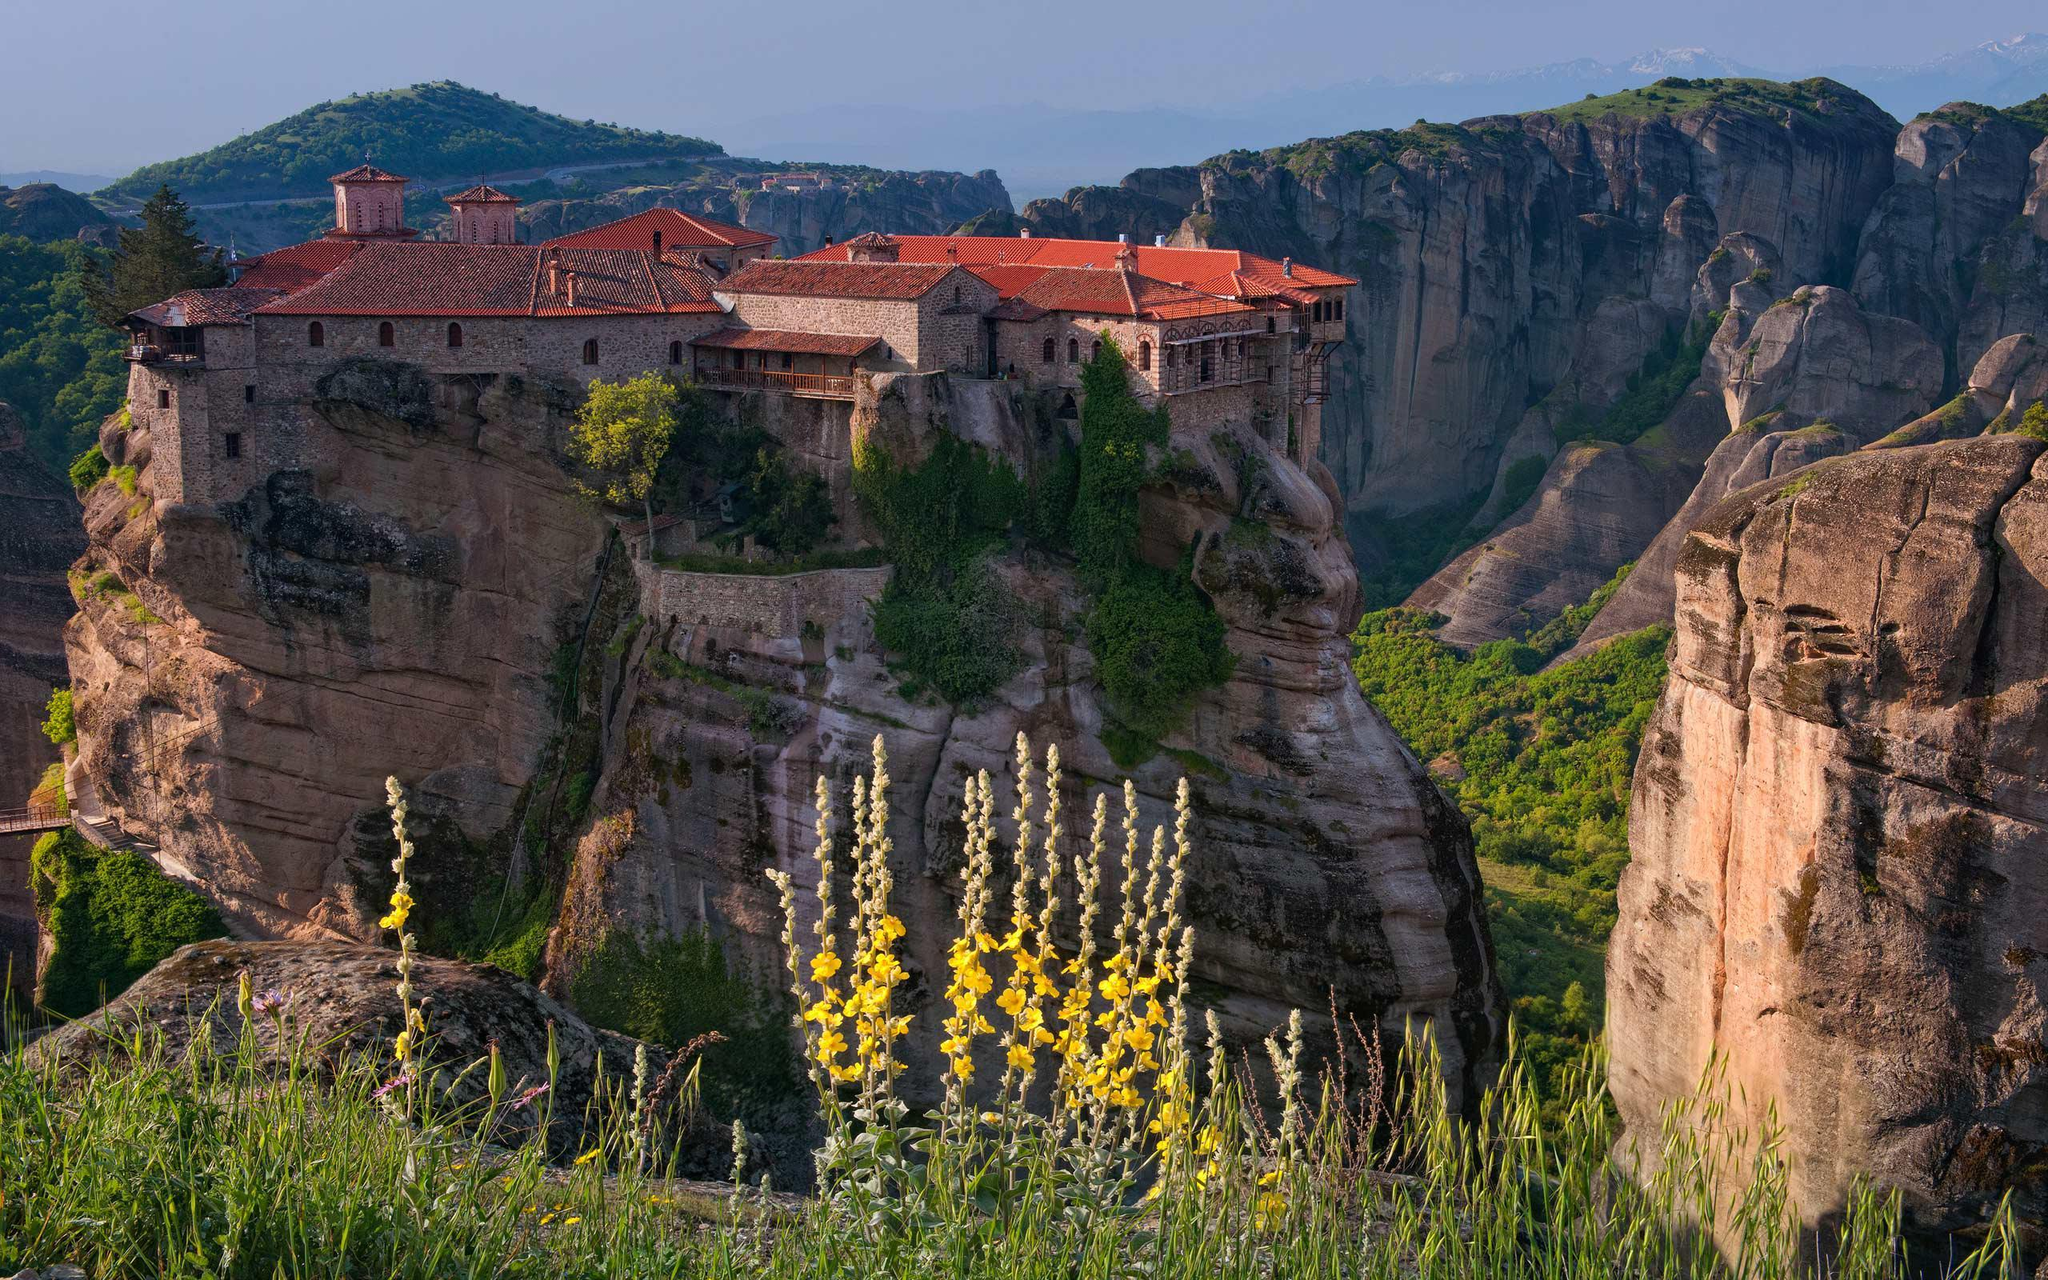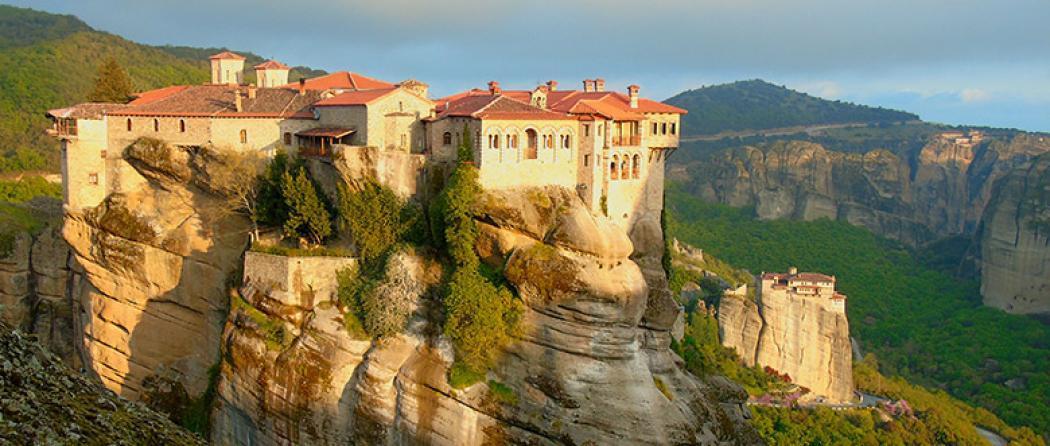The first image is the image on the left, the second image is the image on the right. Evaluate the accuracy of this statement regarding the images: "All images feature buildings constructed on top of large rocks.". Is it true? Answer yes or no. Yes. The first image is the image on the left, the second image is the image on the right. Analyze the images presented: Is the assertion "Left image includes bright yellow foliage in front of a steep rocky formation topped with an orangish-roofed building." valid? Answer yes or no. Yes. 